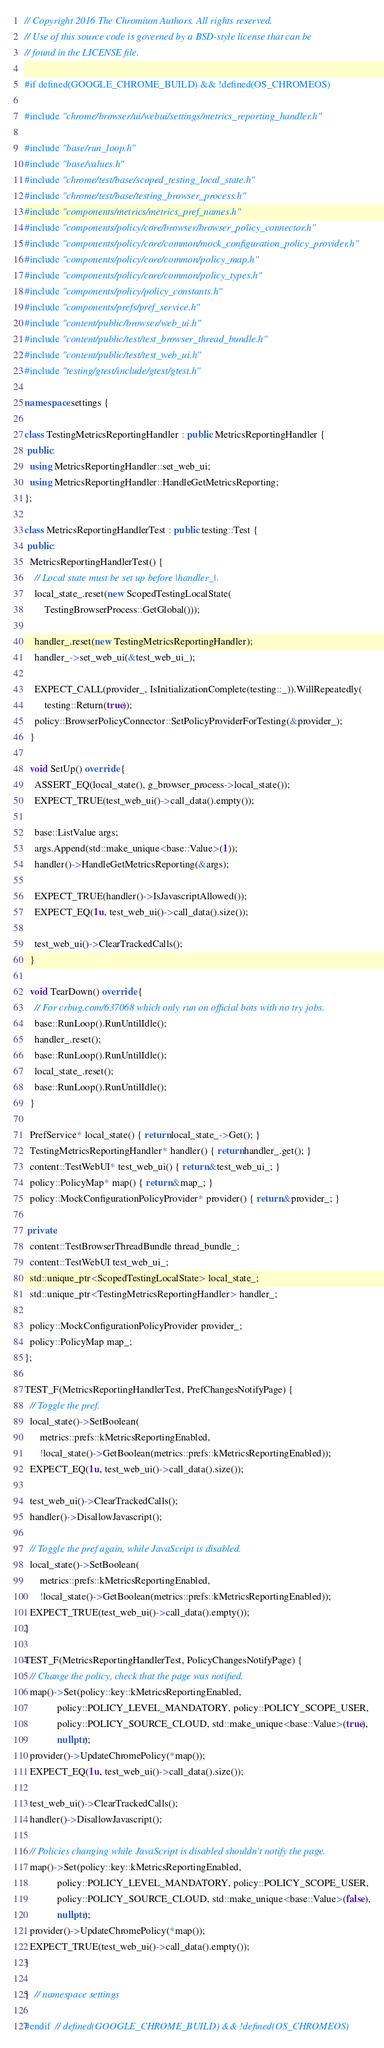<code> <loc_0><loc_0><loc_500><loc_500><_C++_>// Copyright 2016 The Chromium Authors. All rights reserved.
// Use of this source code is governed by a BSD-style license that can be
// found in the LICENSE file.

#if defined(GOOGLE_CHROME_BUILD) && !defined(OS_CHROMEOS)

#include "chrome/browser/ui/webui/settings/metrics_reporting_handler.h"

#include "base/run_loop.h"
#include "base/values.h"
#include "chrome/test/base/scoped_testing_local_state.h"
#include "chrome/test/base/testing_browser_process.h"
#include "components/metrics/metrics_pref_names.h"
#include "components/policy/core/browser/browser_policy_connector.h"
#include "components/policy/core/common/mock_configuration_policy_provider.h"
#include "components/policy/core/common/policy_map.h"
#include "components/policy/core/common/policy_types.h"
#include "components/policy/policy_constants.h"
#include "components/prefs/pref_service.h"
#include "content/public/browser/web_ui.h"
#include "content/public/test/test_browser_thread_bundle.h"
#include "content/public/test/test_web_ui.h"
#include "testing/gtest/include/gtest/gtest.h"

namespace settings {

class TestingMetricsReportingHandler : public MetricsReportingHandler {
 public:
  using MetricsReportingHandler::set_web_ui;
  using MetricsReportingHandler::HandleGetMetricsReporting;
};

class MetricsReportingHandlerTest : public testing::Test {
 public:
  MetricsReportingHandlerTest() {
    // Local state must be set up before |handler_|.
    local_state_.reset(new ScopedTestingLocalState(
        TestingBrowserProcess::GetGlobal()));

    handler_.reset(new TestingMetricsReportingHandler);
    handler_->set_web_ui(&test_web_ui_);

    EXPECT_CALL(provider_, IsInitializationComplete(testing::_)).WillRepeatedly(
        testing::Return(true));
    policy::BrowserPolicyConnector::SetPolicyProviderForTesting(&provider_);
  }

  void SetUp() override {
    ASSERT_EQ(local_state(), g_browser_process->local_state());
    EXPECT_TRUE(test_web_ui()->call_data().empty());

    base::ListValue args;
    args.Append(std::make_unique<base::Value>(1));
    handler()->HandleGetMetricsReporting(&args);

    EXPECT_TRUE(handler()->IsJavascriptAllowed());
    EXPECT_EQ(1u, test_web_ui()->call_data().size());

    test_web_ui()->ClearTrackedCalls();
  }

  void TearDown() override {
    // For crbug.com/637068 which only run on official bots with no try jobs.
    base::RunLoop().RunUntilIdle();
    handler_.reset();
    base::RunLoop().RunUntilIdle();
    local_state_.reset();
    base::RunLoop().RunUntilIdle();
  }

  PrefService* local_state() { return local_state_->Get(); }
  TestingMetricsReportingHandler* handler() { return handler_.get(); }
  content::TestWebUI* test_web_ui() { return &test_web_ui_; }
  policy::PolicyMap* map() { return &map_; }
  policy::MockConfigurationPolicyProvider* provider() { return &provider_; }

 private:
  content::TestBrowserThreadBundle thread_bundle_;
  content::TestWebUI test_web_ui_;
  std::unique_ptr<ScopedTestingLocalState> local_state_;
  std::unique_ptr<TestingMetricsReportingHandler> handler_;

  policy::MockConfigurationPolicyProvider provider_;
  policy::PolicyMap map_;
};

TEST_F(MetricsReportingHandlerTest, PrefChangesNotifyPage) {
  // Toggle the pref.
  local_state()->SetBoolean(
      metrics::prefs::kMetricsReportingEnabled,
      !local_state()->GetBoolean(metrics::prefs::kMetricsReportingEnabled));
  EXPECT_EQ(1u, test_web_ui()->call_data().size());

  test_web_ui()->ClearTrackedCalls();
  handler()->DisallowJavascript();

  // Toggle the pref again, while JavaScript is disabled.
  local_state()->SetBoolean(
      metrics::prefs::kMetricsReportingEnabled,
      !local_state()->GetBoolean(metrics::prefs::kMetricsReportingEnabled));
  EXPECT_TRUE(test_web_ui()->call_data().empty());
}

TEST_F(MetricsReportingHandlerTest, PolicyChangesNotifyPage) {
  // Change the policy, check that the page was notified.
  map()->Set(policy::key::kMetricsReportingEnabled,
             policy::POLICY_LEVEL_MANDATORY, policy::POLICY_SCOPE_USER,
             policy::POLICY_SOURCE_CLOUD, std::make_unique<base::Value>(true),
             nullptr);
  provider()->UpdateChromePolicy(*map());
  EXPECT_EQ(1u, test_web_ui()->call_data().size());

  test_web_ui()->ClearTrackedCalls();
  handler()->DisallowJavascript();

  // Policies changing while JavaScript is disabled shouldn't notify the page.
  map()->Set(policy::key::kMetricsReportingEnabled,
             policy::POLICY_LEVEL_MANDATORY, policy::POLICY_SCOPE_USER,
             policy::POLICY_SOURCE_CLOUD, std::make_unique<base::Value>(false),
             nullptr);
  provider()->UpdateChromePolicy(*map());
  EXPECT_TRUE(test_web_ui()->call_data().empty());
}

}  // namespace settings

#endif  // defined(GOOGLE_CHROME_BUILD) && !defined(OS_CHROMEOS)
</code> 